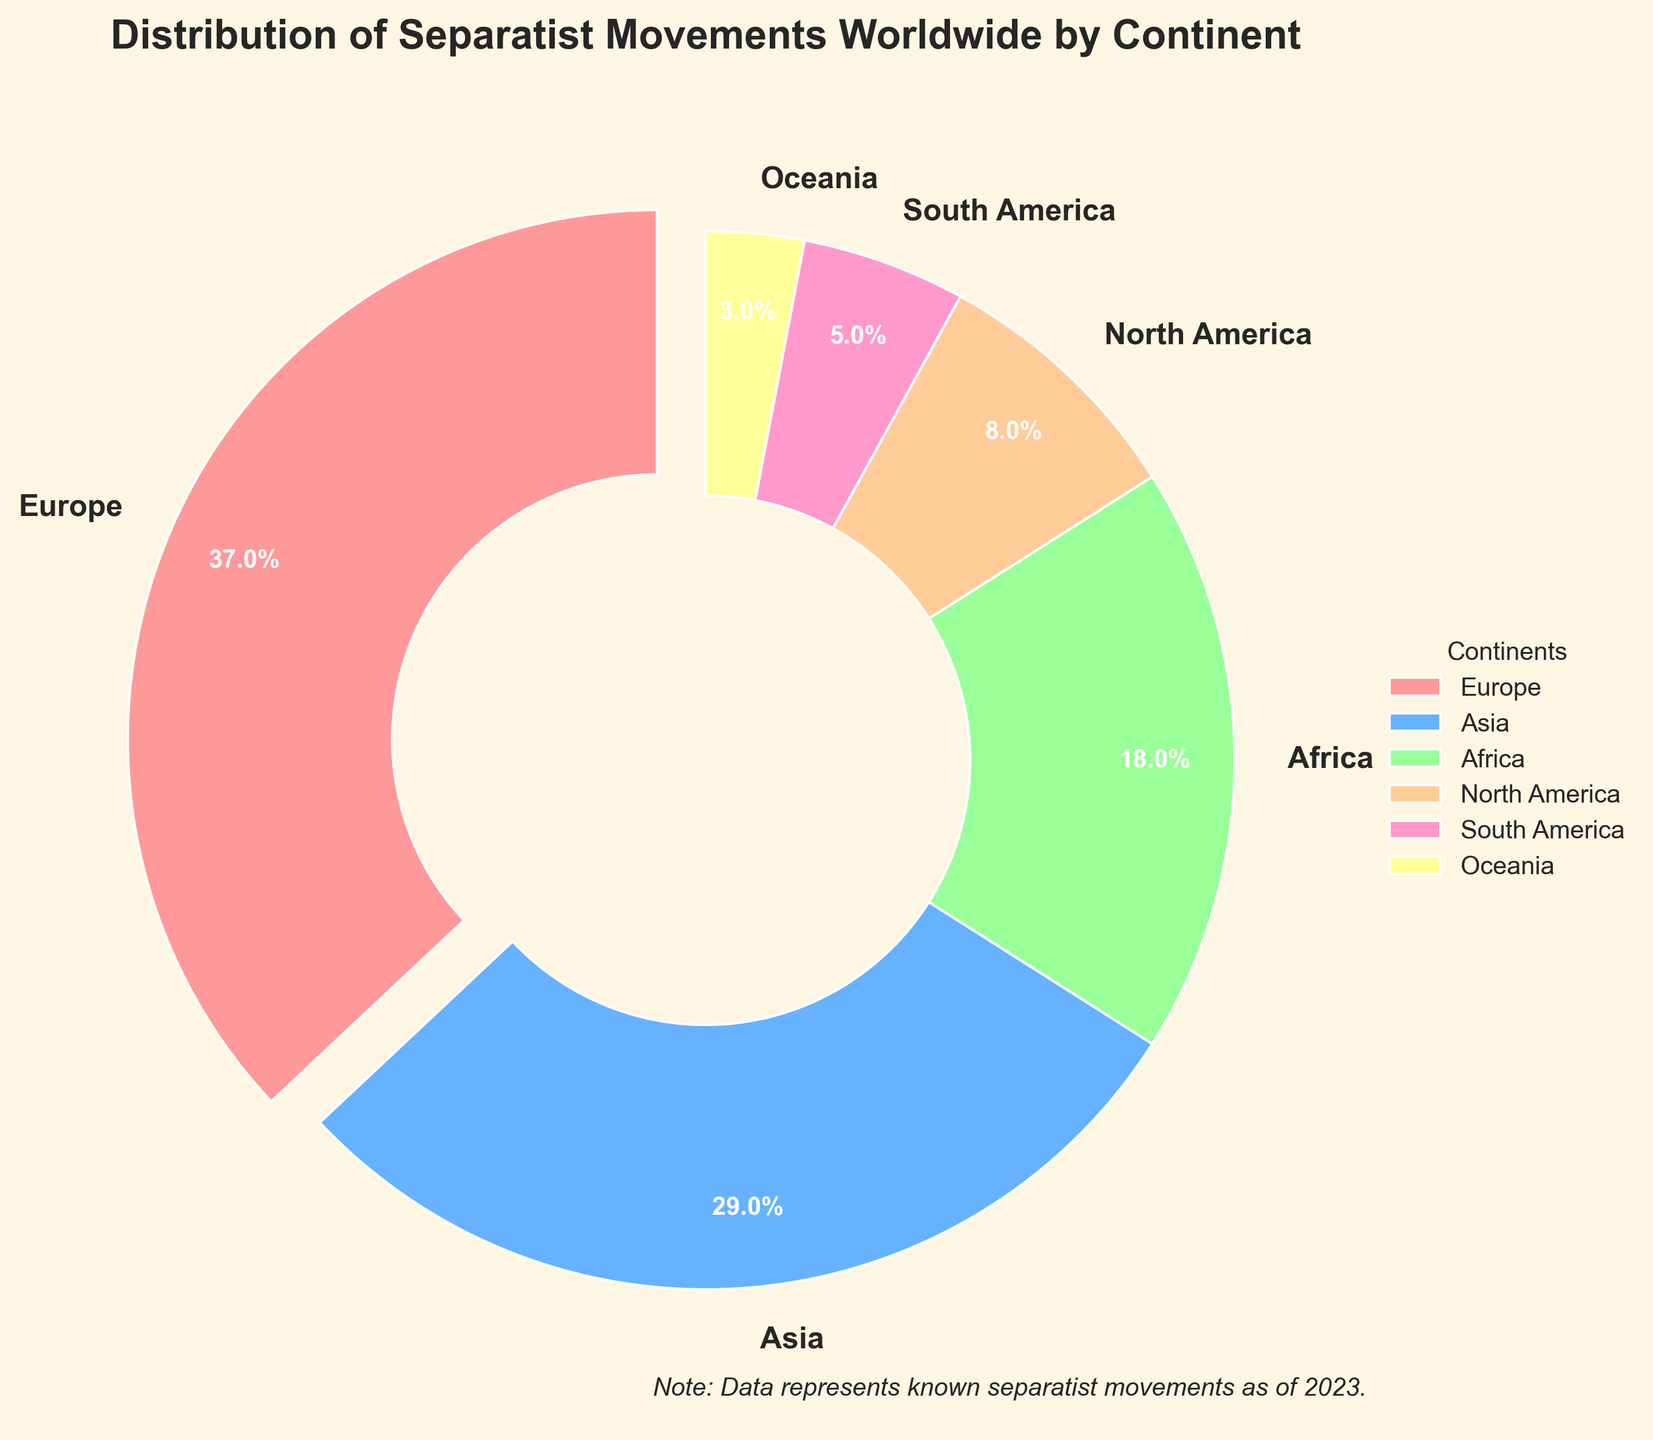What percentage of the separatist movements are in Europe? The pie chart shows that Europe has the largest wedge. The label on Europe's wedge shows 37 separatist movements. The percentage is already calculated in the chart as 37.0%.
Answer: 37.0% Compare the number of separatist movements in Asia and Africa. Which continent has more? Asia has 29 movements, while Africa has 18. By comparing these two values, Asia has more separatist movements than Africa.
Answer: Asia How many more separatist movements are there in Europe compared to North America? Europe has 37 separatist movements, and North America has 8. The difference is 37 - 8 = 29.
Answer: 29 What is the total number of separatist movements in continents other than Europe? The total is calculated by summing movements in all continents except Europe: 29 (Asia) + 18 (Africa) + 8 (North America) + 5 (South America) + 3 (Oceania) = 63.
Answer: 63 Which color represents South America in the pie chart, and what percentage of movements does it have? South America is represented by the pinkish color and its wedge shows 5 separatist movements, which is 5.0% of the total as labeled on the pie chart.
Answer: Pinkish, 5.0% What percentage of total separatist movements do North America and Oceania collectively represent? North America has 8 movements and Oceania has 3. The combined total is 8 + 3 = 11. To find the percentage: (11 / 100) * 100 = 11%.
Answer: 11% Compare the numbers of separatist movements in Oceania and South America. How much fewer movements does Oceania have than South America? South America has 5 movements, while Oceania has 3. The difference is 5 - 3 = 2. Oceania has 2 fewer movements than South America.
Answer: 2 Identify the color corresponding to Africa and describe its percentage share. Africa is represented by a greenish color in the chart, and the label shows it has 18 separatist movements, which contributes to 18.0% of the total.
Answer: Greenish, 18.0% How does Europe’s proportion of separatist movements compare to the rest of the continents combined? Europe has 37 movements. The total number for all continents combined is 100. The rest of the continents have 100 - 37 = 63 movements. Europe’s proportion is 37 out of 100, while the rest of the continents combined is 63 out of 100. Thus, Europe has a greater proportion.
Answer: Europe has a greater proportion 